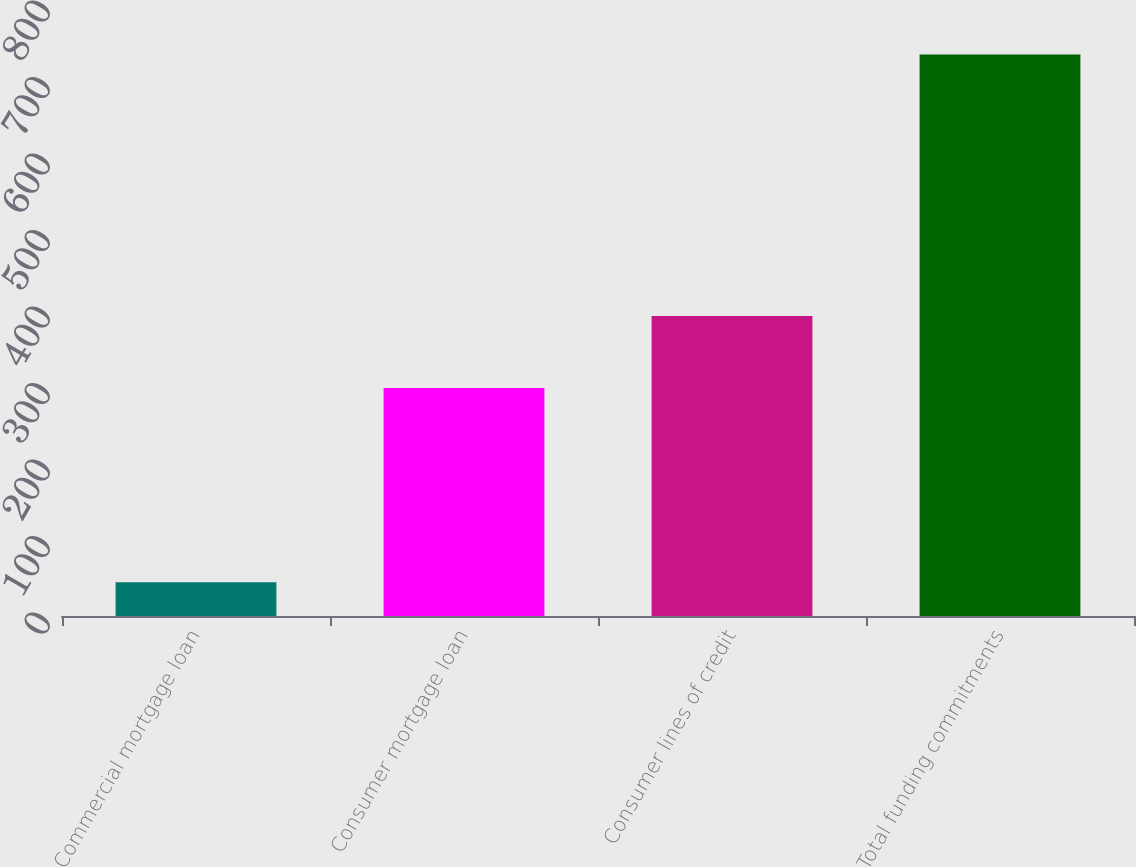Convert chart. <chart><loc_0><loc_0><loc_500><loc_500><bar_chart><fcel>Commercial mortgage loan<fcel>Consumer mortgage loan<fcel>Consumer lines of credit<fcel>Total funding commitments<nl><fcel>44<fcel>298<fcel>392<fcel>734<nl></chart> 